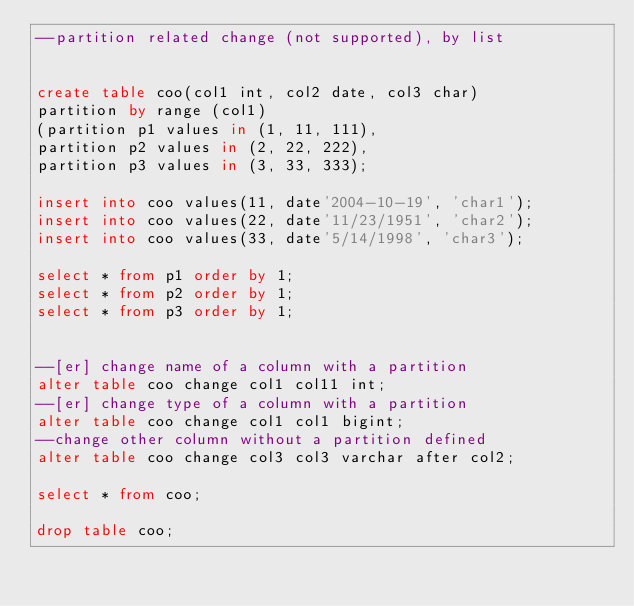<code> <loc_0><loc_0><loc_500><loc_500><_SQL_>--partition related change (not supported), by list


create table coo(col1 int, col2 date, col3 char)
partition by range (col1)
(partition p1 values in (1, 11, 111),
partition p2 values in (2, 22, 222),
partition p3 values in (3, 33, 333);

insert into coo values(11, date'2004-10-19', 'char1');
insert into coo values(22, date'11/23/1951', 'char2');
insert into coo values(33, date'5/14/1998', 'char3');

select * from p1 order by 1;
select * from p2 order by 1;
select * from p3 order by 1;


--[er] change name of a column with a partition
alter table coo change col1 col11 int;
--[er] change type of a column with a partition
alter table coo change col1 col1 bigint;
--change other column without a partition defined
alter table coo change col3 col3 varchar after col2;

select * from coo;

drop table coo;
</code> 